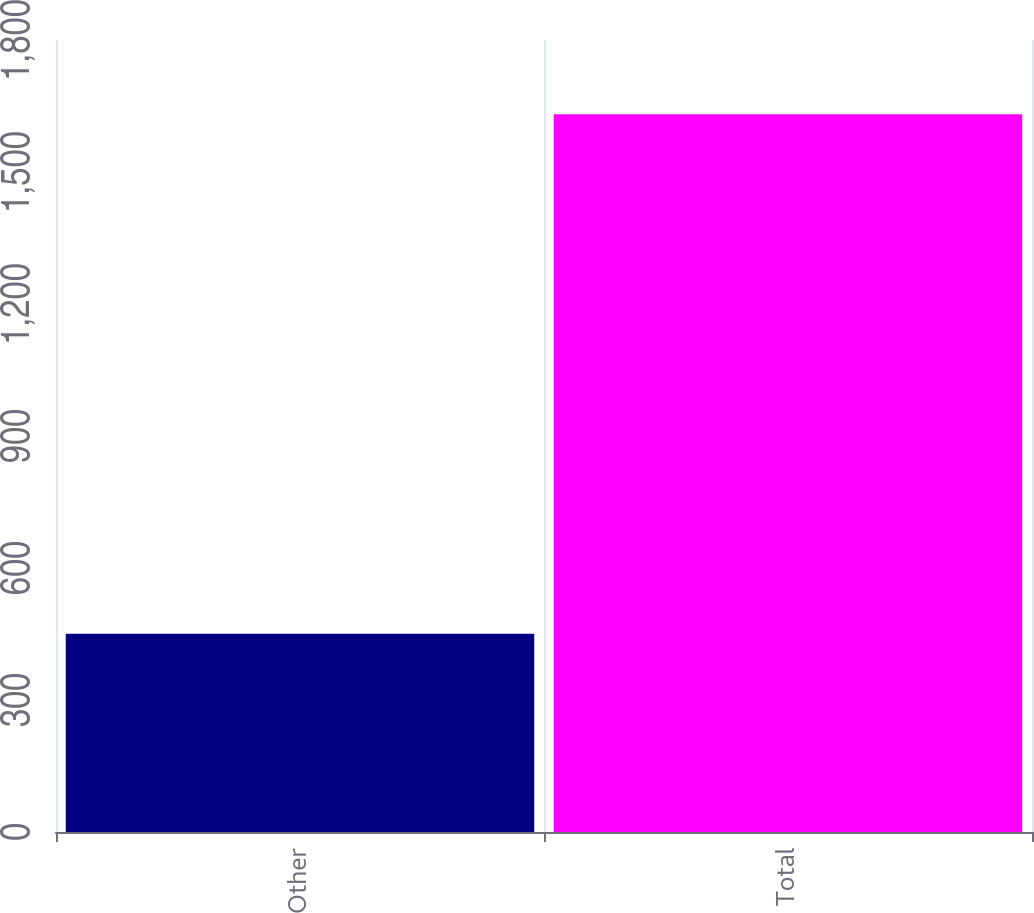<chart> <loc_0><loc_0><loc_500><loc_500><bar_chart><fcel>Other<fcel>Total<nl><fcel>450.4<fcel>1631<nl></chart> 